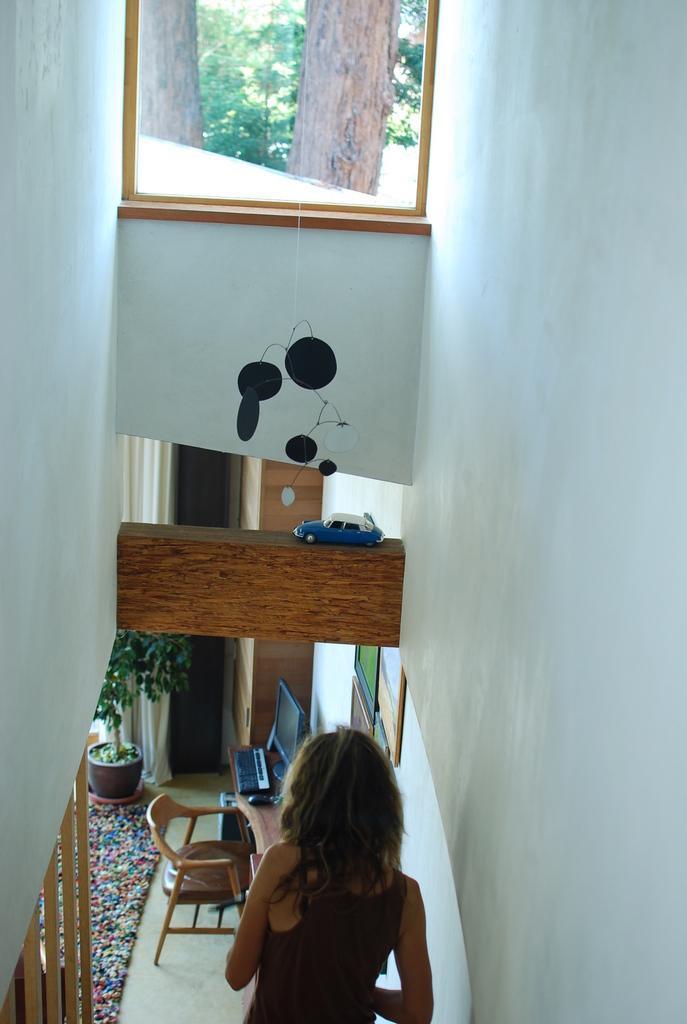How would you summarize this image in a sentence or two? In this image I see a window, a toy car, a woman, chair, desktop and a plant. 